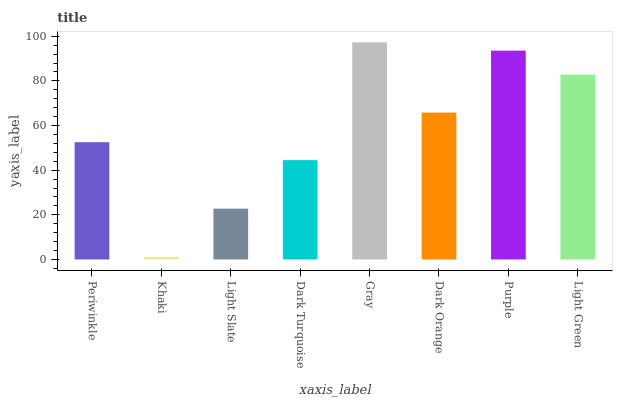Is Light Slate the minimum?
Answer yes or no. No. Is Light Slate the maximum?
Answer yes or no. No. Is Light Slate greater than Khaki?
Answer yes or no. Yes. Is Khaki less than Light Slate?
Answer yes or no. Yes. Is Khaki greater than Light Slate?
Answer yes or no. No. Is Light Slate less than Khaki?
Answer yes or no. No. Is Dark Orange the high median?
Answer yes or no. Yes. Is Periwinkle the low median?
Answer yes or no. Yes. Is Gray the high median?
Answer yes or no. No. Is Dark Orange the low median?
Answer yes or no. No. 